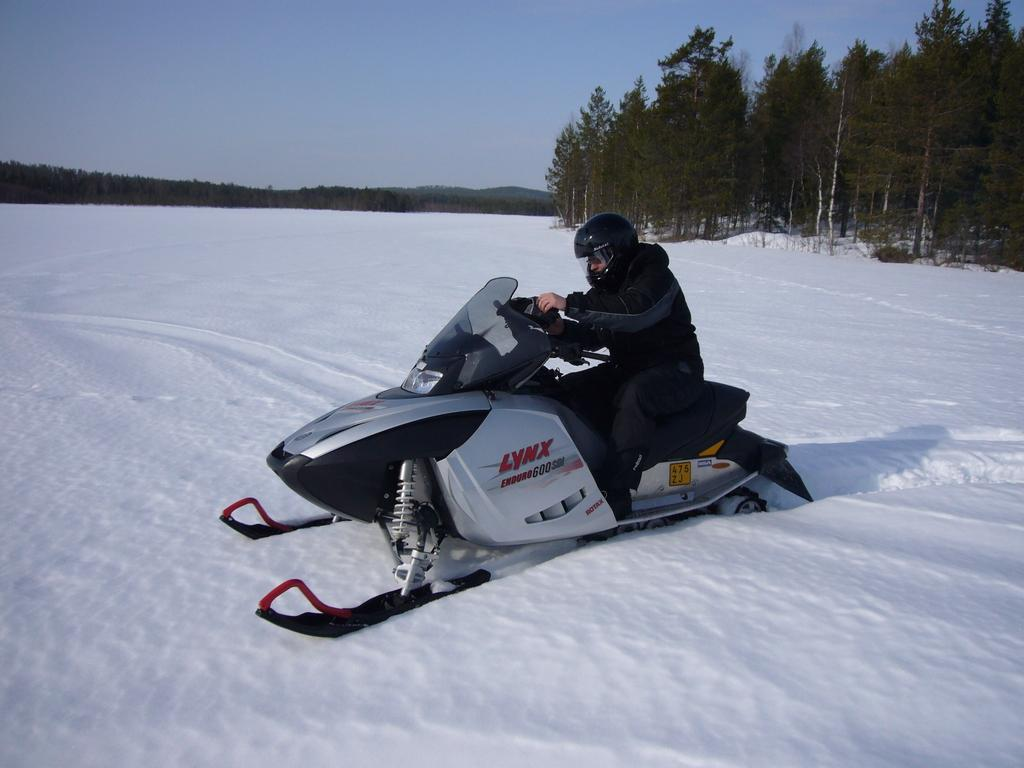What is the person in the image doing? There is a person driving a vehicle in the image. What is the terrain like in the image? The vehicle is on snow in the image. What can be seen in the background of the image? There are trees and the sky visible in the background of the image. What type of songs can be heard playing from the ornament in the image? There is no ornament present in the image, and therefore no songs can be heard playing from it. 